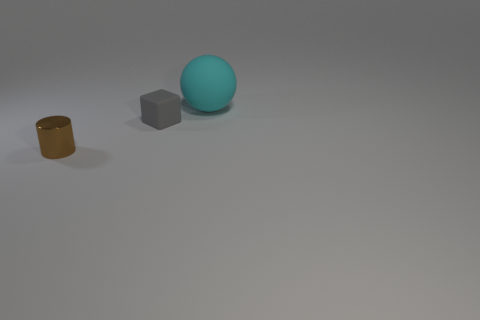Is there anything else that has the same size as the cyan object?
Ensure brevity in your answer.  No. How many objects are in front of the rubber ball and behind the metallic cylinder?
Provide a short and direct response. 1. The small object behind the small brown shiny cylinder is what color?
Give a very brief answer. Gray. What is the size of the thing that is the same material as the sphere?
Offer a terse response. Small. What number of objects are behind the rubber thing in front of the big cyan rubber sphere?
Provide a succinct answer. 1. What number of tiny gray blocks are to the left of the brown object?
Make the answer very short. 0. There is a rubber thing in front of the object behind the small object that is right of the tiny metallic cylinder; what is its color?
Give a very brief answer. Gray. There is a tiny object that is behind the tiny brown cylinder; is it the same color as the object on the right side of the small gray block?
Your answer should be very brief. No. There is a object to the right of the small thing behind the cylinder; what is its shape?
Provide a short and direct response. Sphere. Is there a brown thing of the same size as the cyan matte thing?
Your answer should be compact. No. 